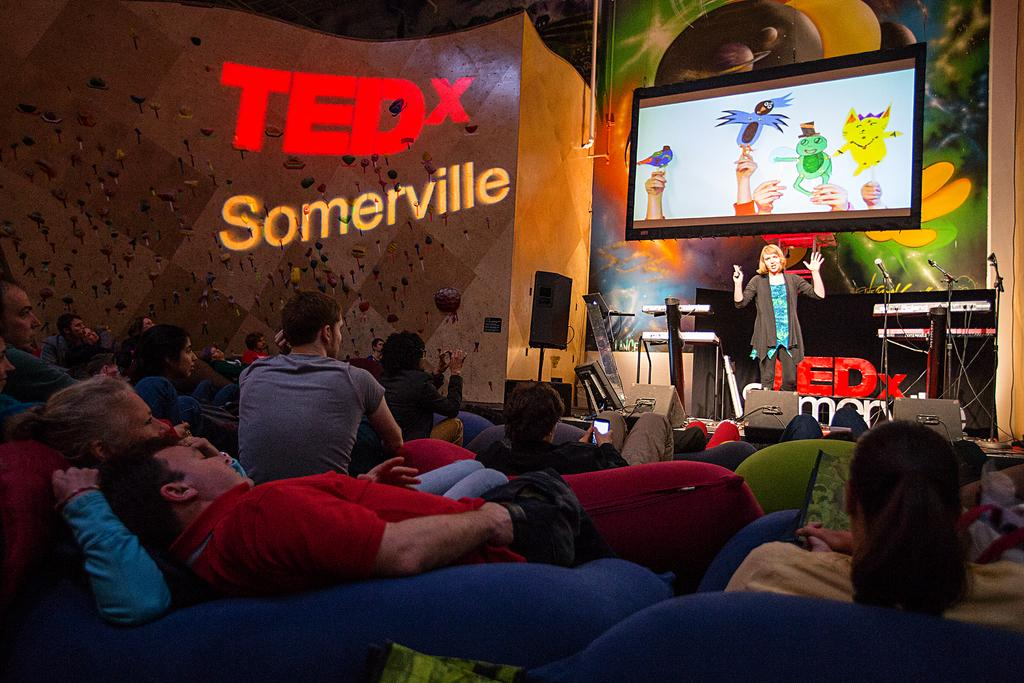What type of structure can be seen in the image? There is a wall in the image. What is the main object in the image? There is a screen in the image. Are there any people present in the image? Yes, there are people in the image. What type of furniture is visible in the image? There are sofas in the image. What device is present for producing sound? There is a sound box in the image. Can you describe the woman in the image? A woman is standing in the image, and she is wearing a black color jacket. What type of joke can be seen in the image? There is no joke present in the image; it features a wall, screen, people, sofas, a sound box, and a woman wearing a black color jacket. Is there a harbor visible in the image? No, there is no harbor present in the image. 